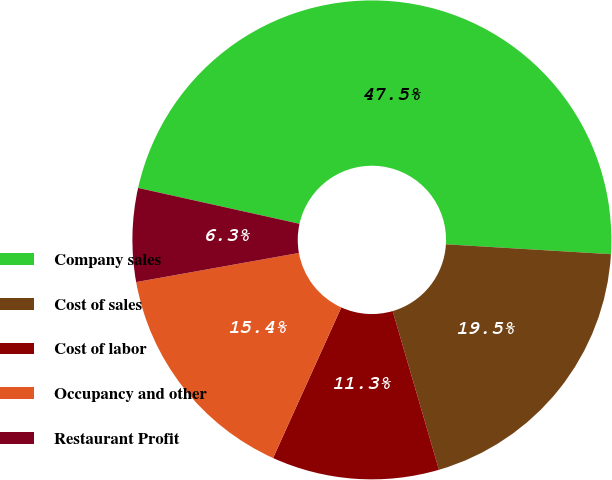<chart> <loc_0><loc_0><loc_500><loc_500><pie_chart><fcel>Company sales<fcel>Cost of sales<fcel>Cost of labor<fcel>Occupancy and other<fcel>Restaurant Profit<nl><fcel>47.47%<fcel>19.53%<fcel>11.29%<fcel>15.41%<fcel>6.3%<nl></chart> 